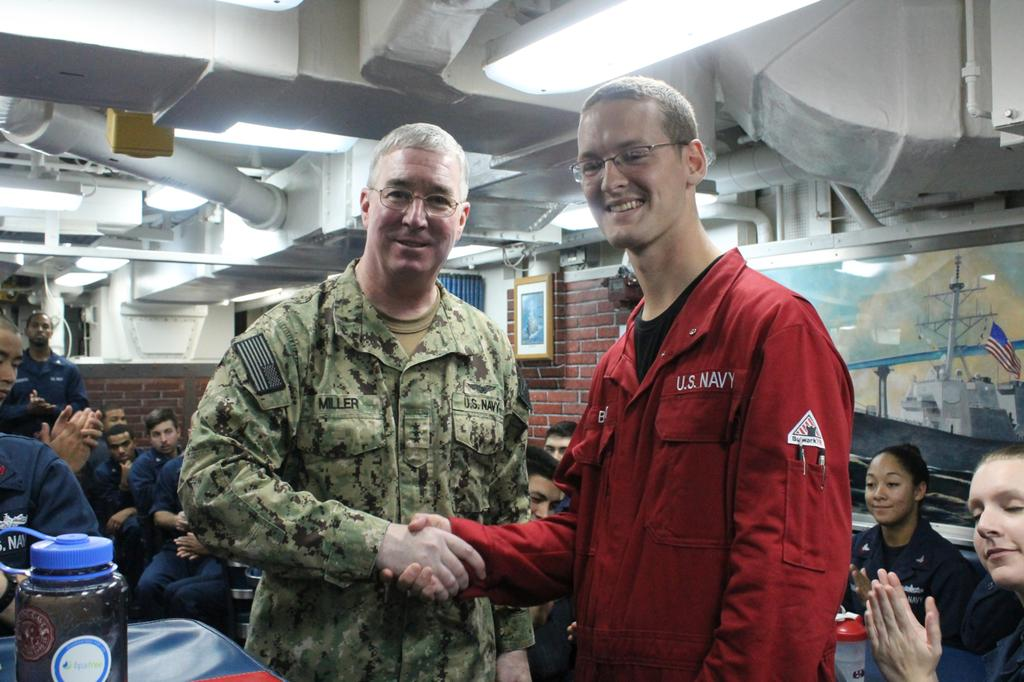How many people are in the image? There are people in the image, but the exact number is not specified. What are the people doing in the image? Some of the people are sitting, and some are standing. What can be seen around the people in the image? There are objects around the people. What is visible at the top of the image? Pipes and lights are visible at the top of the image. What type of harmony is being played by the people in the image? There is no indication of music or harmony in the image; the people are simply sitting and standing. What type of apparel are the people wearing in the image? The facts provided do not mention the clothing or apparel of the people in the image. 